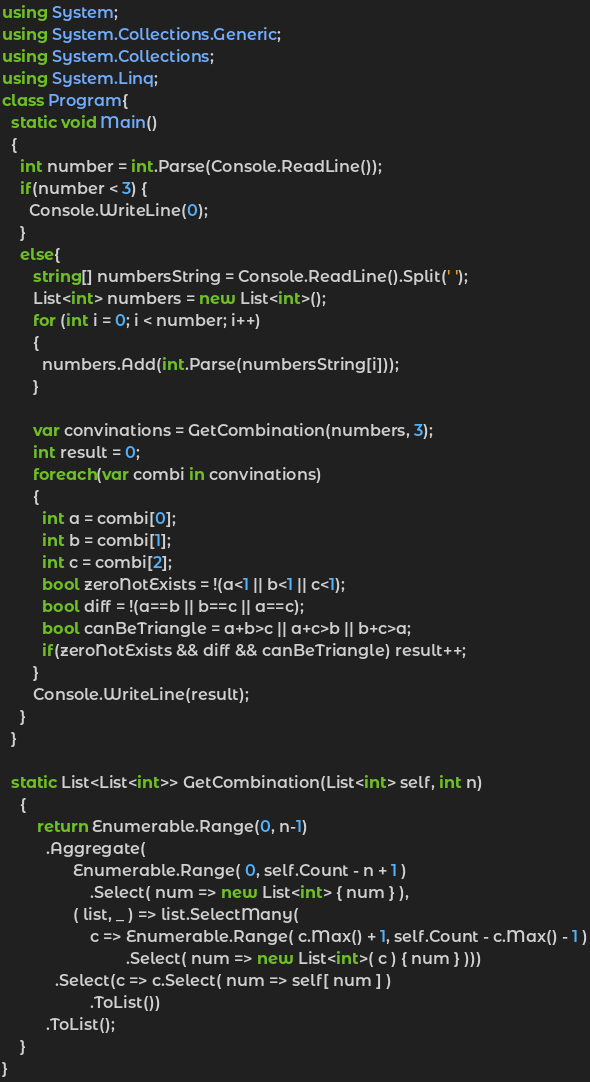<code> <loc_0><loc_0><loc_500><loc_500><_C#_>using System;
using System.Collections.Generic;
using System.Collections;
using System.Linq;
class Program{
  static void Main()
  {
    int number = int.Parse(Console.ReadLine());
    if(number < 3) {
      Console.WriteLine(0);
    }
    else{
       string[] numbersString = Console.ReadLine().Split(' ');
       List<int> numbers = new List<int>();
       for (int i = 0; i < number; i++)
       {
         numbers.Add(int.Parse(numbersString[i]));
       }
    
       var convinations = GetCombination(numbers, 3);
       int result = 0;
       foreach(var combi in convinations)
       {
         int a = combi[0];
         int b = combi[1];
         int c = combi[2];
         bool zeroNotExists = !(a<1 || b<1 || c<1);
         bool diff = !(a==b || b==c || a==c);
         bool canBeTriangle = a+b>c || a+c>b || b+c>a;
         if(zeroNotExists && diff && canBeTriangle) result++;
       }
       Console.WriteLine(result);
    }
  }
  
  static List<List<int>> GetCombination(List<int> self, int n)
    {
        return Enumerable.Range(0, n-1)
          .Aggregate(
                Enumerable.Range( 0, self.Count - n + 1 )
                    .Select( num => new List<int> { num } ),
                ( list, _ ) => list.SelectMany(
                    c => Enumerable.Range( c.Max() + 1, self.Count - c.Max() - 1 )
                            .Select( num => new List<int>( c ) { num } )))
            .Select(c => c.Select( num => self[ num ] )
                    .ToList())
          .ToList();
    }
}
</code> 